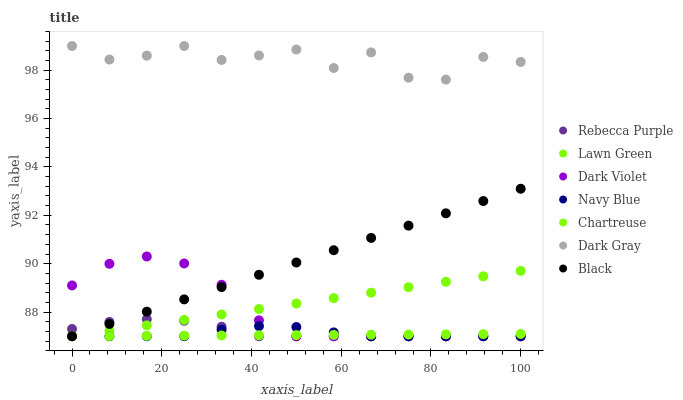Does Chartreuse have the minimum area under the curve?
Answer yes or no. Yes. Does Dark Gray have the maximum area under the curve?
Answer yes or no. Yes. Does Navy Blue have the minimum area under the curve?
Answer yes or no. No. Does Navy Blue have the maximum area under the curve?
Answer yes or no. No. Is Chartreuse the smoothest?
Answer yes or no. Yes. Is Dark Gray the roughest?
Answer yes or no. Yes. Is Navy Blue the smoothest?
Answer yes or no. No. Is Navy Blue the roughest?
Answer yes or no. No. Does Lawn Green have the lowest value?
Answer yes or no. Yes. Does Dark Gray have the lowest value?
Answer yes or no. No. Does Dark Gray have the highest value?
Answer yes or no. Yes. Does Navy Blue have the highest value?
Answer yes or no. No. Is Navy Blue less than Dark Gray?
Answer yes or no. Yes. Is Dark Gray greater than Rebecca Purple?
Answer yes or no. Yes. Does Navy Blue intersect Dark Violet?
Answer yes or no. Yes. Is Navy Blue less than Dark Violet?
Answer yes or no. No. Is Navy Blue greater than Dark Violet?
Answer yes or no. No. Does Navy Blue intersect Dark Gray?
Answer yes or no. No. 